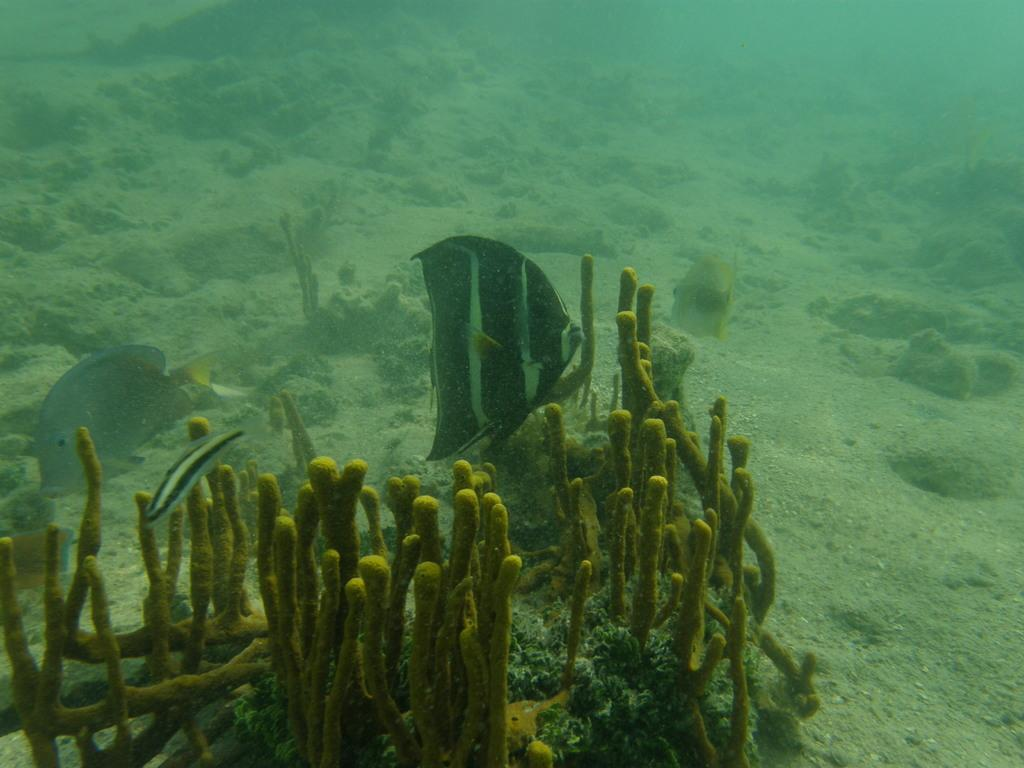What is visible in the image? Water is visible in the image. What can be found in the water? There are fishes and plants in the water. Can you see a kettle boiling water in the image? No, there is no kettle present in the image. What type of clouds can be seen in the image? There are no clouds visible in the image, as it features water with fishes and plants. 